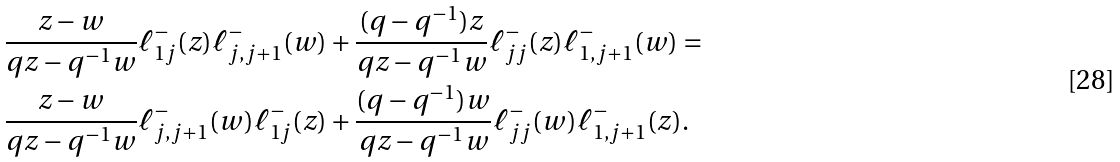Convert formula to latex. <formula><loc_0><loc_0><loc_500><loc_500>& \frac { z - w } { q z - q ^ { - 1 } w } \ell ^ { - } _ { 1 j } ( z ) \ell ^ { - } _ { j , j + 1 } ( w ) + \frac { ( q - q ^ { - 1 } ) z } { q z - q ^ { - 1 } w } \ell ^ { - } _ { j j } ( z ) \ell ^ { - } _ { 1 , j + 1 } ( w ) = \\ & \frac { z - w } { q z - q ^ { - 1 } w } \ell ^ { - } _ { j , j + 1 } ( w ) \ell ^ { - } _ { 1 j } ( z ) + \frac { ( q - q ^ { - 1 } ) w } { q z - q ^ { - 1 } w } \ell ^ { - } _ { j j } ( w ) \ell ^ { - } _ { 1 , j + 1 } ( z ) .</formula> 